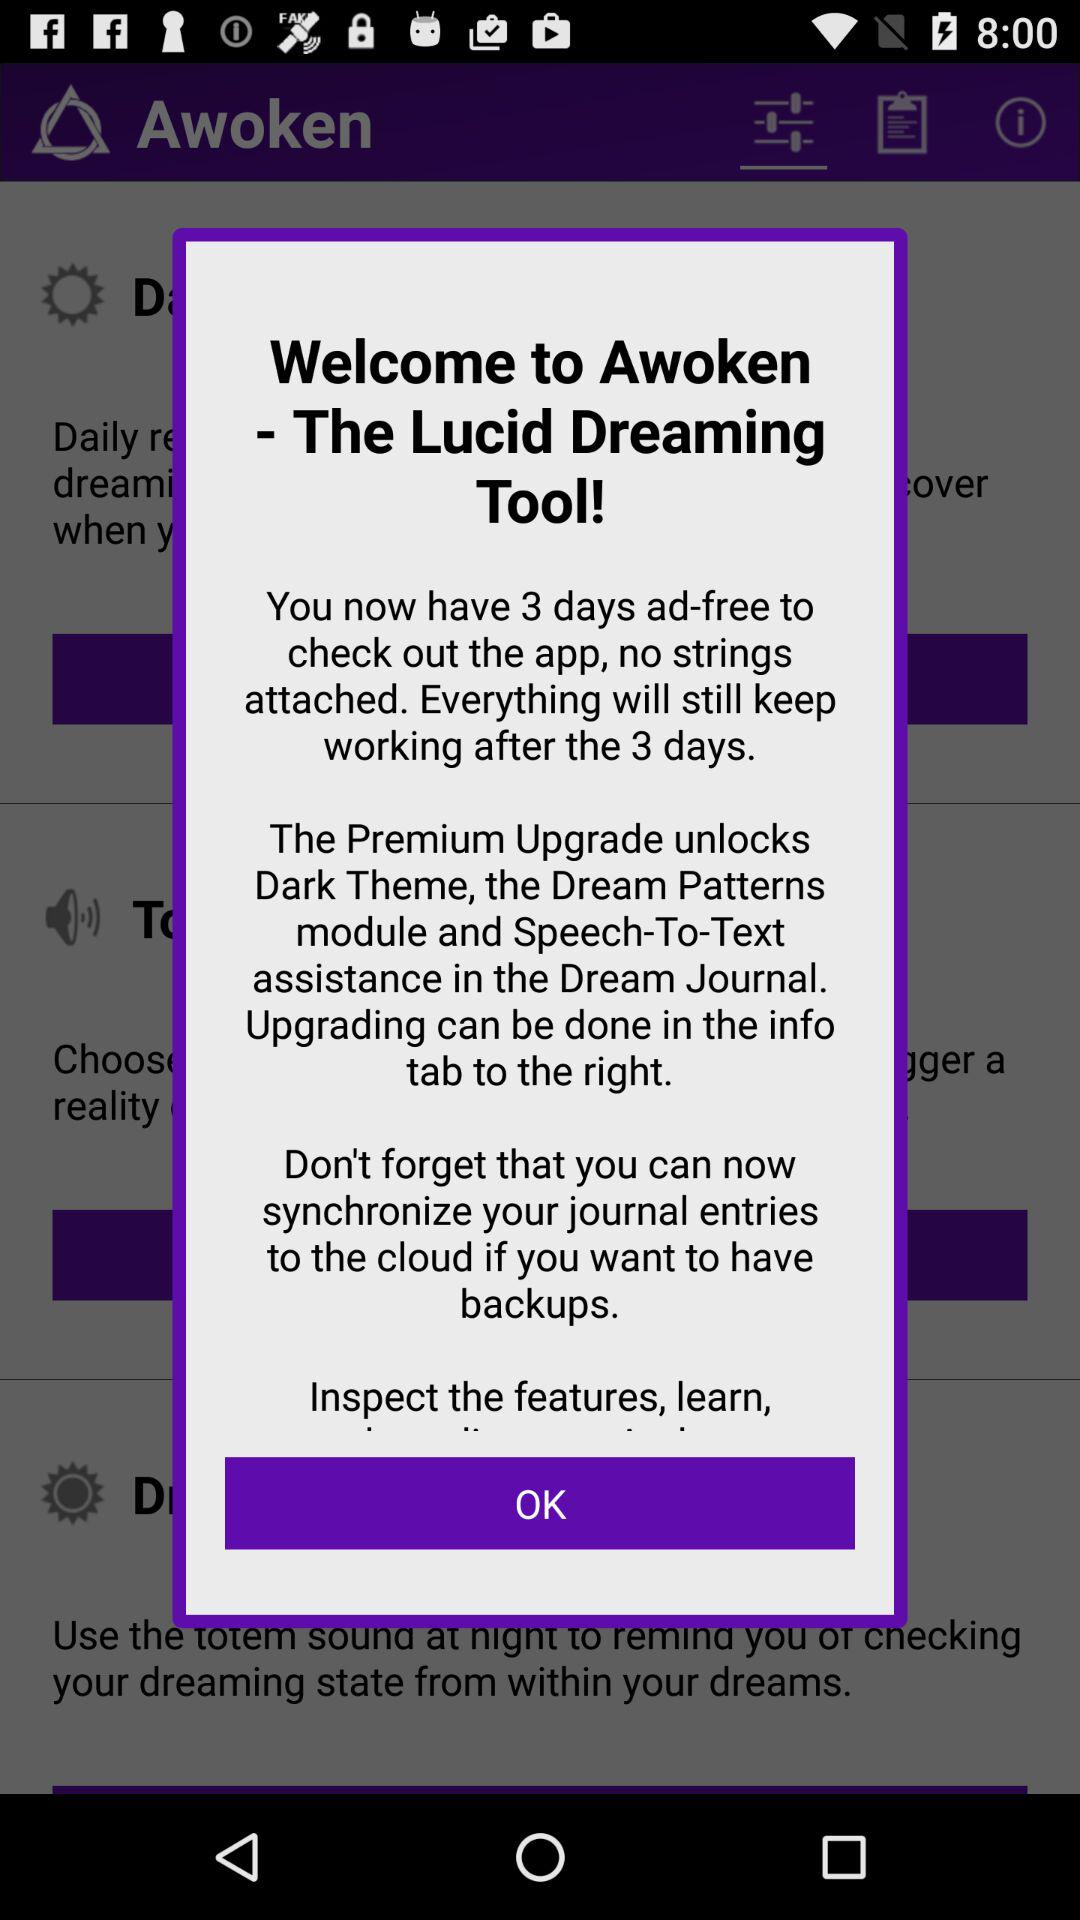What is the application name? The application name is "Awoken". 